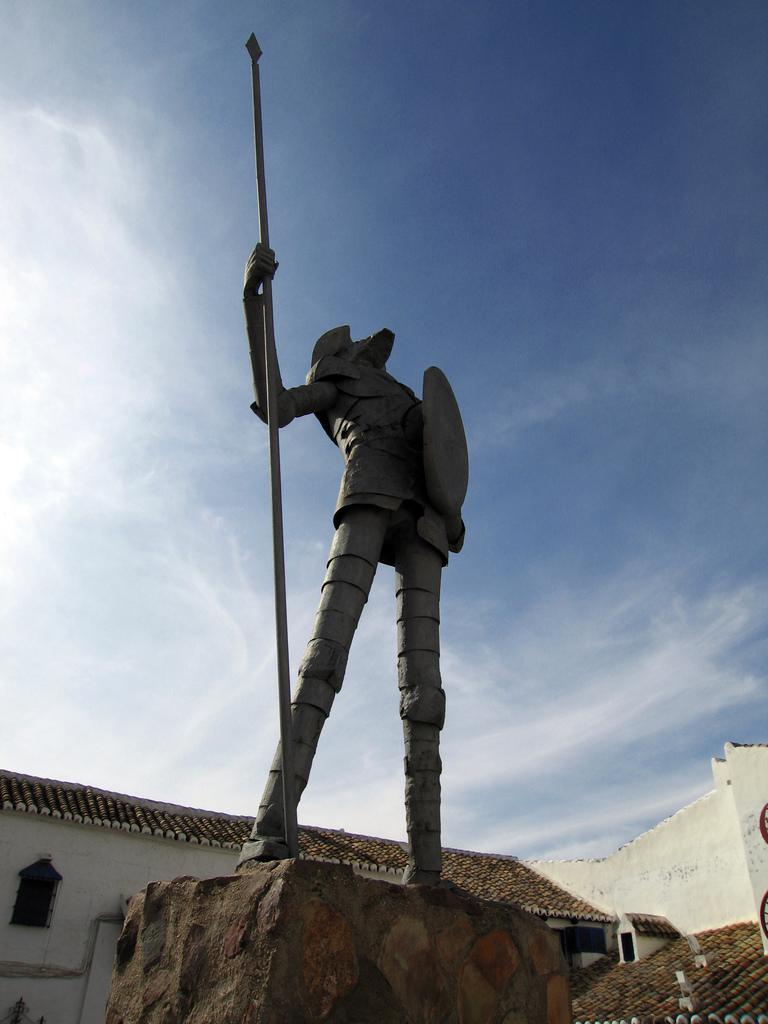Please provide a concise description of this image. In this image, we can see a statue on an object. We can see some houses and the sky with clouds. 